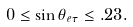Convert formula to latex. <formula><loc_0><loc_0><loc_500><loc_500>0 \leq \sin \theta _ { e \tau } \leq . 2 3 .</formula> 